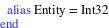<code> <loc_0><loc_0><loc_500><loc_500><_Crystal_>  alias Entity = Int32
end
</code> 